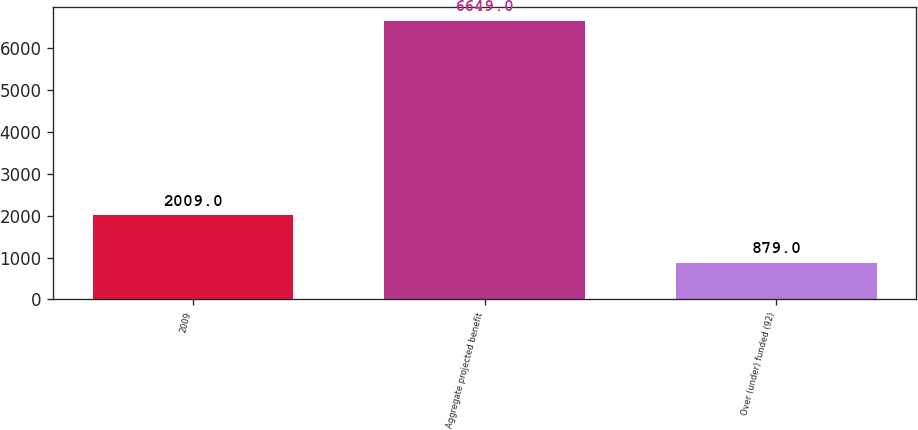<chart> <loc_0><loc_0><loc_500><loc_500><bar_chart><fcel>2009<fcel>Aggregate projected benefit<fcel>Over (under) funded (92)<nl><fcel>2009<fcel>6649<fcel>879<nl></chart> 